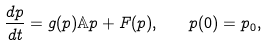Convert formula to latex. <formula><loc_0><loc_0><loc_500><loc_500>\frac { d p } { d t } = g ( p ) \mathbb { A } p + F ( p ) , \quad p ( 0 ) = p _ { 0 } ,</formula> 